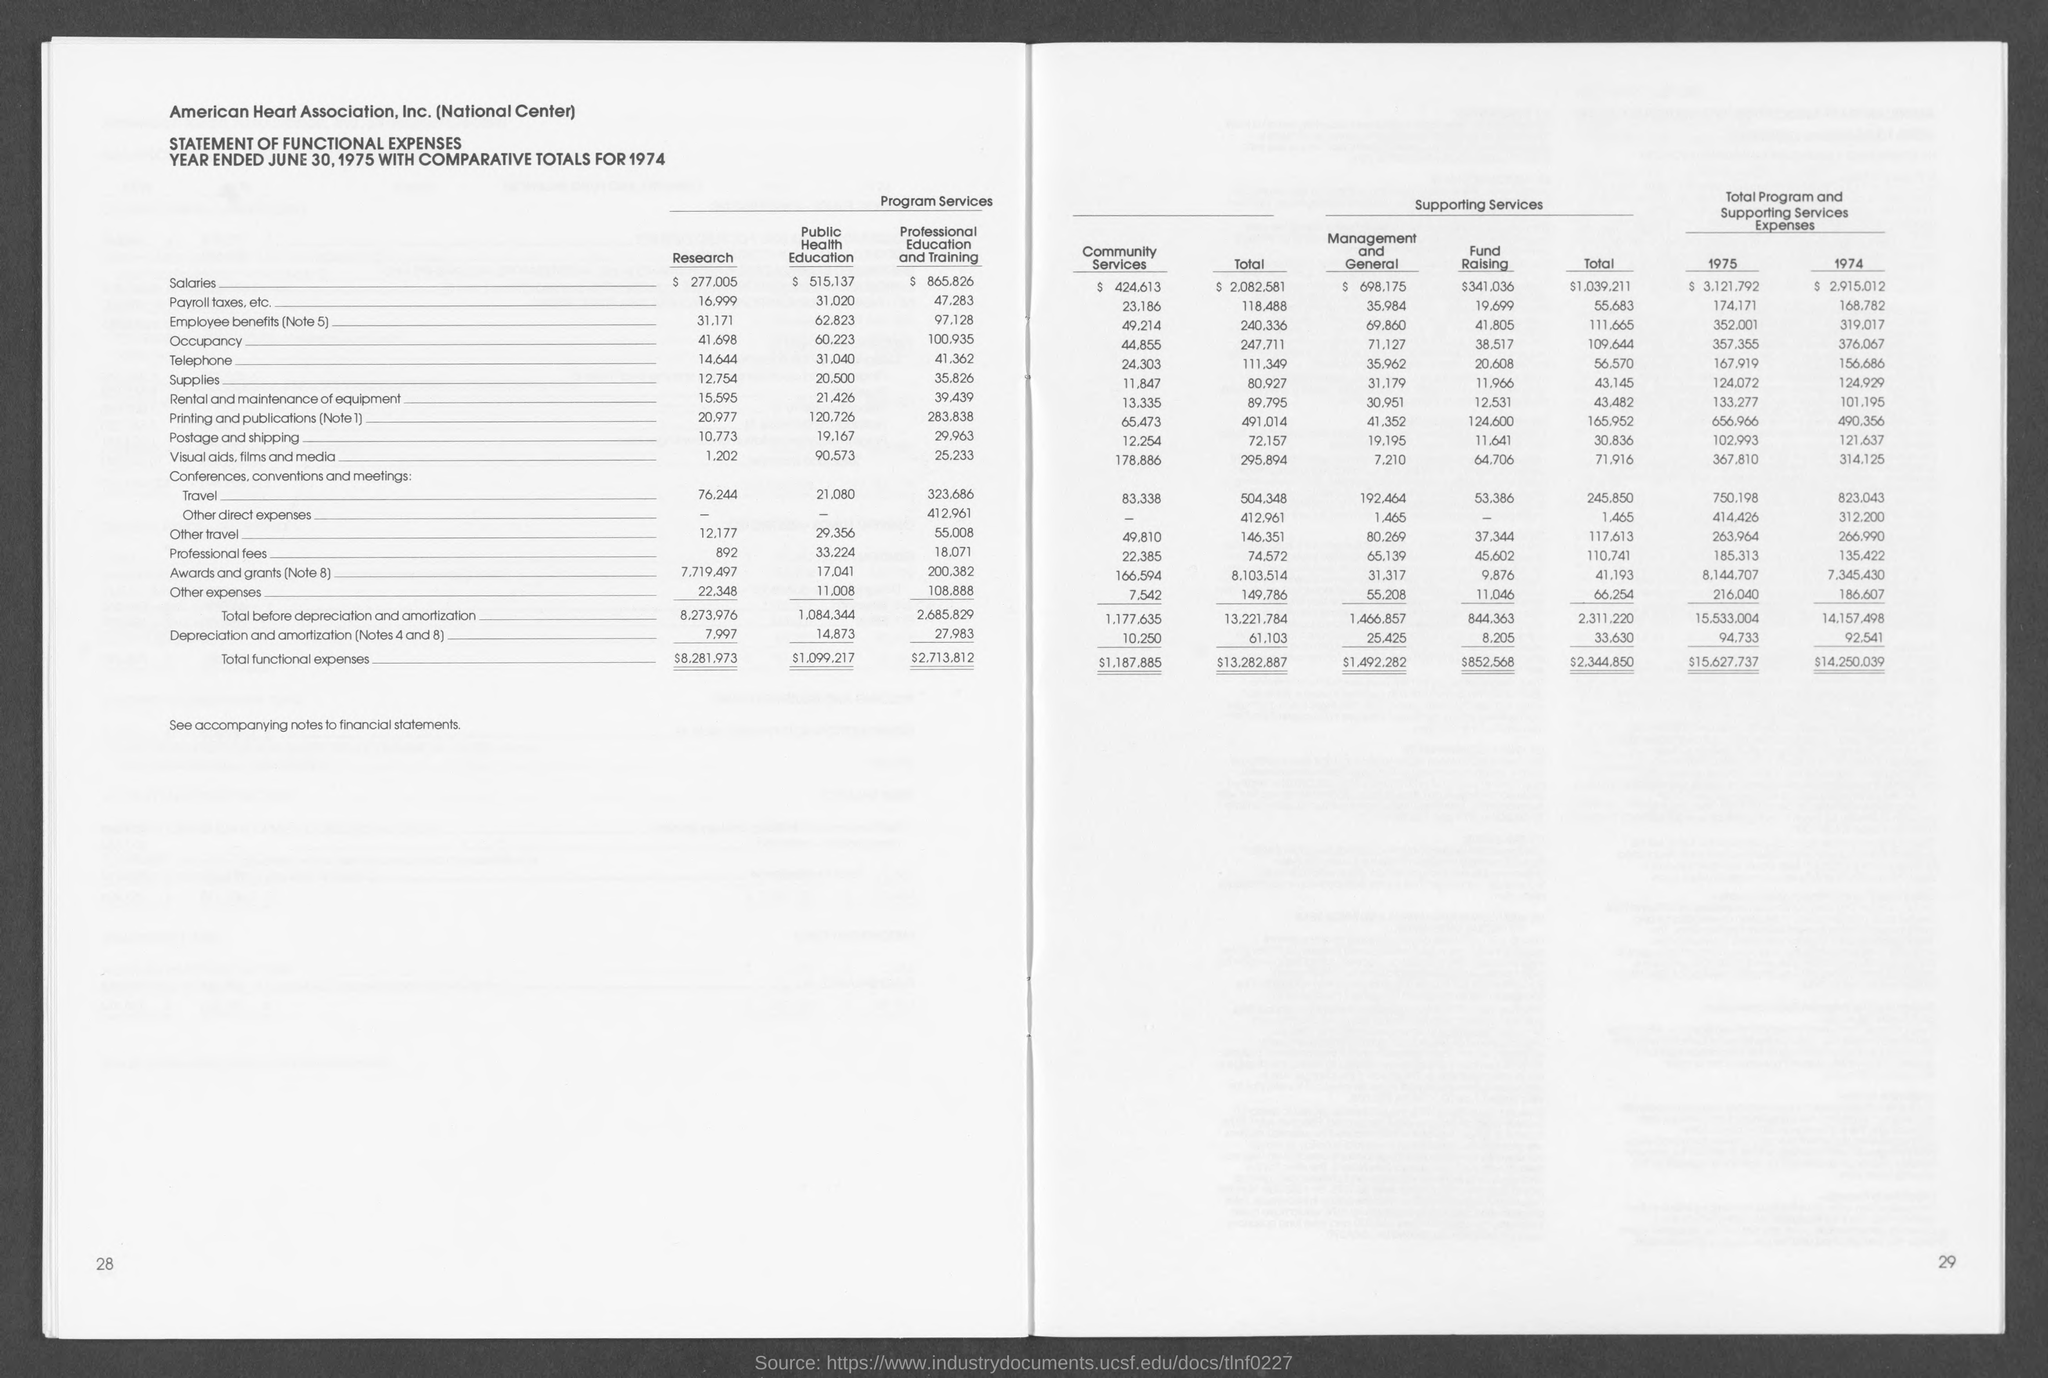What is the name of the association?
Keep it short and to the point. AMERICAN HEART ASSOCIATION, INC. What type of statement is this as per the heading of the document?
Ensure brevity in your answer.  Statement of functional expenses. The statement shows comparative totals for which year?
Make the answer very short. 1974. What is the date given as year-end?
Offer a very short reply. JUNE 30, 1975. What is the entry for 'Total functional expenses' under the column named 'Research'?
Offer a very short reply. $8,281,973. 